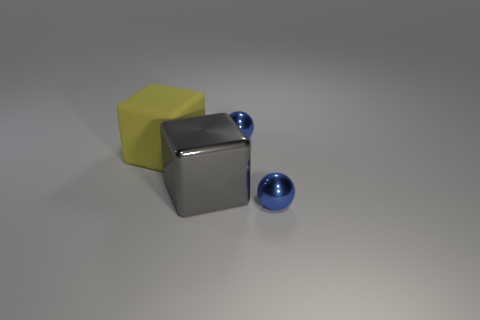Are there any large brown metallic balls?
Make the answer very short. No. There is another thing that is the same shape as the large yellow rubber thing; what is its material?
Give a very brief answer. Metal. There is a metallic thing that is behind the large block to the left of the big gray object that is to the right of the big rubber block; what is its shape?
Offer a very short reply. Sphere. What number of other big gray objects are the same shape as the rubber thing?
Give a very brief answer. 1. Does the ball behind the large gray cube have the same color as the small metallic ball that is in front of the yellow matte cube?
Give a very brief answer. Yes. What is the material of the other object that is the same size as the rubber thing?
Make the answer very short. Metal. Are there any rubber cubes of the same size as the gray metallic cube?
Provide a succinct answer. Yes. Is the number of gray things in front of the gray object less than the number of large blocks?
Provide a succinct answer. Yes. Are there fewer big matte cubes that are right of the large matte block than tiny spheres that are in front of the gray block?
Make the answer very short. Yes. How many blocks are either red rubber objects or yellow matte objects?
Provide a short and direct response. 1. 